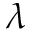<formula> <loc_0><loc_0><loc_500><loc_500>\lambda</formula> 